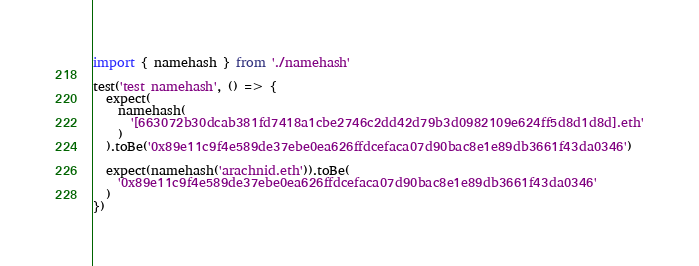<code> <loc_0><loc_0><loc_500><loc_500><_JavaScript_>import { namehash } from './namehash'

test('test namehash', () => {
  expect(
    namehash(
      '[663072b30dcab381fd7418a1cbe2746c2dd42d79b3d0982109e624ff5d8d1d8d].eth'
    )
  ).toBe('0x89e11c9f4e589de37ebe0ea626ffdcefaca07d90bac8e1e89db3661f43da0346')

  expect(namehash('arachnid.eth')).toBe(
    '0x89e11c9f4e589de37ebe0ea626ffdcefaca07d90bac8e1e89db3661f43da0346'
  )
})
</code> 